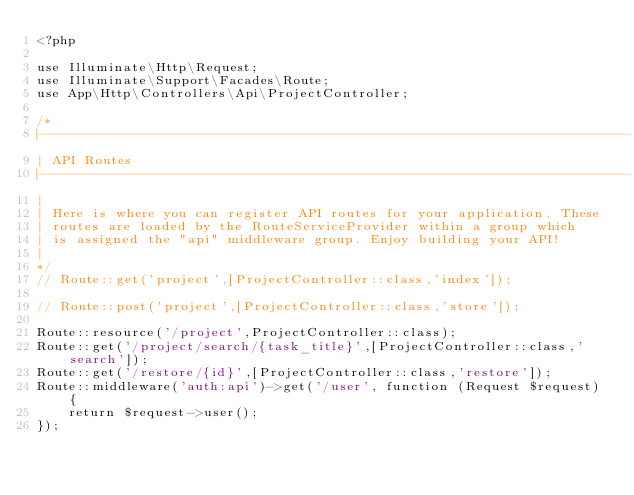Convert code to text. <code><loc_0><loc_0><loc_500><loc_500><_PHP_><?php

use Illuminate\Http\Request;
use Illuminate\Support\Facades\Route;
use App\Http\Controllers\Api\ProjectController; 

/*
|--------------------------------------------------------------------------
| API Routes
|--------------------------------------------------------------------------
|
| Here is where you can register API routes for your application. These
| routes are loaded by the RouteServiceProvider within a group which
| is assigned the "api" middleware group. Enjoy building your API!
|
*/
// Route::get('project',[ProjectController::class,'index']);

// Route::post('project',[ProjectController::class,'store']);

Route::resource('/project',ProjectController::class);
Route::get('/project/search/{task_title}',[ProjectController::class,'search']);
Route::get('/restore/{id}',[ProjectController::class,'restore']);
Route::middleware('auth:api')->get('/user', function (Request $request) {
    return $request->user();
});
</code> 